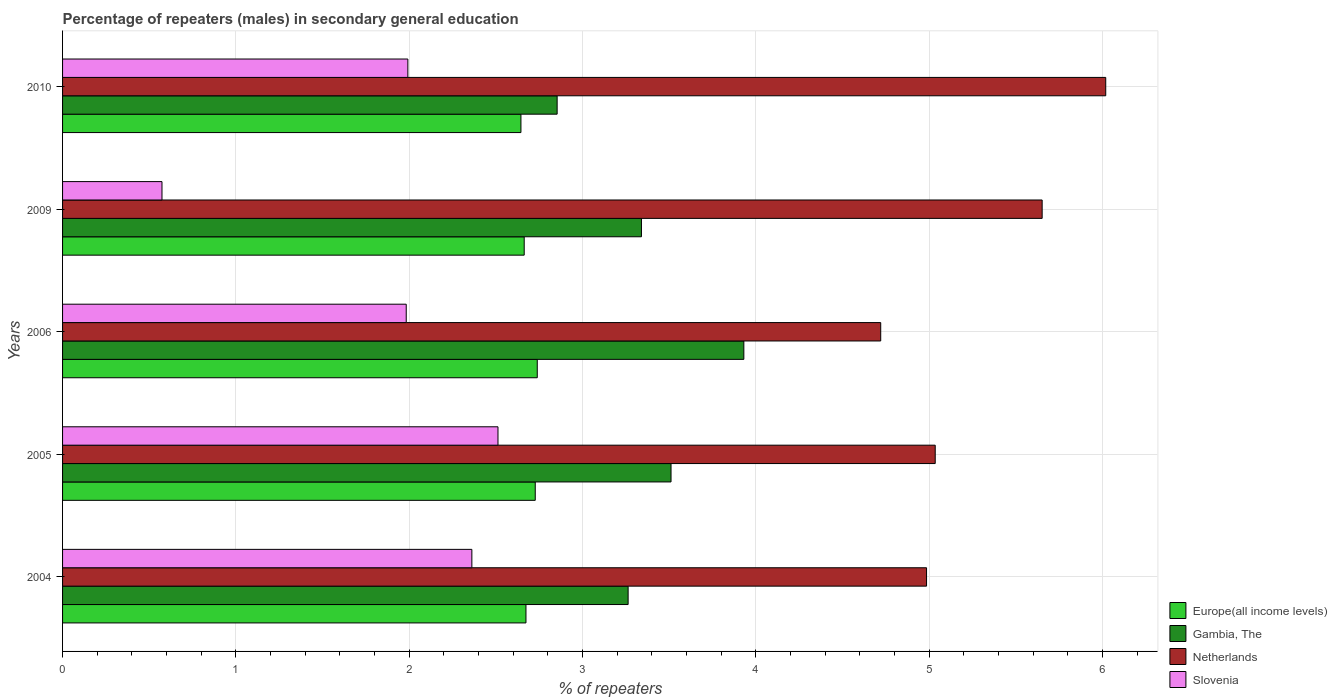How many different coloured bars are there?
Keep it short and to the point. 4. How many groups of bars are there?
Provide a succinct answer. 5. Are the number of bars on each tick of the Y-axis equal?
Your answer should be very brief. Yes. What is the label of the 3rd group of bars from the top?
Provide a short and direct response. 2006. What is the percentage of male repeaters in Gambia, The in 2004?
Provide a succinct answer. 3.26. Across all years, what is the maximum percentage of male repeaters in Slovenia?
Ensure brevity in your answer.  2.51. Across all years, what is the minimum percentage of male repeaters in Gambia, The?
Offer a terse response. 2.85. What is the total percentage of male repeaters in Gambia, The in the graph?
Your answer should be compact. 16.9. What is the difference between the percentage of male repeaters in Netherlands in 2004 and that in 2005?
Provide a short and direct response. -0.05. What is the difference between the percentage of male repeaters in Netherlands in 2004 and the percentage of male repeaters in Slovenia in 2009?
Your answer should be compact. 4.41. What is the average percentage of male repeaters in Gambia, The per year?
Offer a very short reply. 3.38. In the year 2005, what is the difference between the percentage of male repeaters in Slovenia and percentage of male repeaters in Netherlands?
Make the answer very short. -2.52. In how many years, is the percentage of male repeaters in Europe(all income levels) greater than 1.8 %?
Provide a short and direct response. 5. What is the ratio of the percentage of male repeaters in Europe(all income levels) in 2004 to that in 2010?
Offer a terse response. 1.01. Is the percentage of male repeaters in Gambia, The in 2004 less than that in 2006?
Your answer should be very brief. Yes. Is the difference between the percentage of male repeaters in Slovenia in 2005 and 2010 greater than the difference between the percentage of male repeaters in Netherlands in 2005 and 2010?
Your response must be concise. Yes. What is the difference between the highest and the second highest percentage of male repeaters in Netherlands?
Make the answer very short. 0.37. What is the difference between the highest and the lowest percentage of male repeaters in Gambia, The?
Offer a terse response. 1.08. In how many years, is the percentage of male repeaters in Netherlands greater than the average percentage of male repeaters in Netherlands taken over all years?
Provide a succinct answer. 2. Is the sum of the percentage of male repeaters in Slovenia in 2005 and 2006 greater than the maximum percentage of male repeaters in Europe(all income levels) across all years?
Provide a succinct answer. Yes. What does the 2nd bar from the top in 2004 represents?
Make the answer very short. Netherlands. Is it the case that in every year, the sum of the percentage of male repeaters in Gambia, The and percentage of male repeaters in Slovenia is greater than the percentage of male repeaters in Europe(all income levels)?
Offer a terse response. Yes. How many bars are there?
Provide a succinct answer. 20. Are the values on the major ticks of X-axis written in scientific E-notation?
Your answer should be very brief. No. Does the graph contain any zero values?
Your answer should be compact. No. Where does the legend appear in the graph?
Your response must be concise. Bottom right. How are the legend labels stacked?
Offer a terse response. Vertical. What is the title of the graph?
Make the answer very short. Percentage of repeaters (males) in secondary general education. What is the label or title of the X-axis?
Give a very brief answer. % of repeaters. What is the label or title of the Y-axis?
Offer a very short reply. Years. What is the % of repeaters of Europe(all income levels) in 2004?
Provide a short and direct response. 2.67. What is the % of repeaters in Gambia, The in 2004?
Offer a terse response. 3.26. What is the % of repeaters in Netherlands in 2004?
Make the answer very short. 4.99. What is the % of repeaters in Slovenia in 2004?
Keep it short and to the point. 2.36. What is the % of repeaters of Europe(all income levels) in 2005?
Ensure brevity in your answer.  2.73. What is the % of repeaters in Gambia, The in 2005?
Ensure brevity in your answer.  3.51. What is the % of repeaters of Netherlands in 2005?
Your response must be concise. 5.04. What is the % of repeaters of Slovenia in 2005?
Your answer should be compact. 2.51. What is the % of repeaters in Europe(all income levels) in 2006?
Offer a terse response. 2.74. What is the % of repeaters in Gambia, The in 2006?
Offer a very short reply. 3.93. What is the % of repeaters of Netherlands in 2006?
Make the answer very short. 4.72. What is the % of repeaters of Slovenia in 2006?
Make the answer very short. 1.98. What is the % of repeaters in Europe(all income levels) in 2009?
Give a very brief answer. 2.66. What is the % of repeaters in Gambia, The in 2009?
Your answer should be compact. 3.34. What is the % of repeaters of Netherlands in 2009?
Offer a terse response. 5.65. What is the % of repeaters of Slovenia in 2009?
Ensure brevity in your answer.  0.57. What is the % of repeaters in Europe(all income levels) in 2010?
Keep it short and to the point. 2.64. What is the % of repeaters of Gambia, The in 2010?
Provide a short and direct response. 2.85. What is the % of repeaters of Netherlands in 2010?
Give a very brief answer. 6.02. What is the % of repeaters in Slovenia in 2010?
Keep it short and to the point. 1.99. Across all years, what is the maximum % of repeaters of Europe(all income levels)?
Offer a very short reply. 2.74. Across all years, what is the maximum % of repeaters in Gambia, The?
Provide a succinct answer. 3.93. Across all years, what is the maximum % of repeaters in Netherlands?
Make the answer very short. 6.02. Across all years, what is the maximum % of repeaters of Slovenia?
Make the answer very short. 2.51. Across all years, what is the minimum % of repeaters of Europe(all income levels)?
Offer a very short reply. 2.64. Across all years, what is the minimum % of repeaters of Gambia, The?
Ensure brevity in your answer.  2.85. Across all years, what is the minimum % of repeaters in Netherlands?
Offer a very short reply. 4.72. Across all years, what is the minimum % of repeaters of Slovenia?
Provide a short and direct response. 0.57. What is the total % of repeaters of Europe(all income levels) in the graph?
Provide a succinct answer. 13.45. What is the total % of repeaters of Gambia, The in the graph?
Your answer should be very brief. 16.9. What is the total % of repeaters in Netherlands in the graph?
Ensure brevity in your answer.  26.41. What is the total % of repeaters of Slovenia in the graph?
Make the answer very short. 9.42. What is the difference between the % of repeaters of Europe(all income levels) in 2004 and that in 2005?
Provide a succinct answer. -0.05. What is the difference between the % of repeaters of Gambia, The in 2004 and that in 2005?
Give a very brief answer. -0.25. What is the difference between the % of repeaters of Netherlands in 2004 and that in 2005?
Your answer should be compact. -0.05. What is the difference between the % of repeaters of Slovenia in 2004 and that in 2005?
Offer a very short reply. -0.15. What is the difference between the % of repeaters of Europe(all income levels) in 2004 and that in 2006?
Give a very brief answer. -0.07. What is the difference between the % of repeaters of Gambia, The in 2004 and that in 2006?
Keep it short and to the point. -0.67. What is the difference between the % of repeaters of Netherlands in 2004 and that in 2006?
Keep it short and to the point. 0.26. What is the difference between the % of repeaters of Slovenia in 2004 and that in 2006?
Your response must be concise. 0.38. What is the difference between the % of repeaters of Europe(all income levels) in 2004 and that in 2009?
Your response must be concise. 0.01. What is the difference between the % of repeaters in Gambia, The in 2004 and that in 2009?
Offer a very short reply. -0.08. What is the difference between the % of repeaters in Netherlands in 2004 and that in 2009?
Your response must be concise. -0.67. What is the difference between the % of repeaters of Slovenia in 2004 and that in 2009?
Provide a short and direct response. 1.79. What is the difference between the % of repeaters in Europe(all income levels) in 2004 and that in 2010?
Provide a short and direct response. 0.03. What is the difference between the % of repeaters in Gambia, The in 2004 and that in 2010?
Provide a short and direct response. 0.41. What is the difference between the % of repeaters in Netherlands in 2004 and that in 2010?
Keep it short and to the point. -1.03. What is the difference between the % of repeaters of Slovenia in 2004 and that in 2010?
Your answer should be very brief. 0.37. What is the difference between the % of repeaters in Europe(all income levels) in 2005 and that in 2006?
Provide a succinct answer. -0.01. What is the difference between the % of repeaters in Gambia, The in 2005 and that in 2006?
Give a very brief answer. -0.42. What is the difference between the % of repeaters in Netherlands in 2005 and that in 2006?
Ensure brevity in your answer.  0.31. What is the difference between the % of repeaters in Slovenia in 2005 and that in 2006?
Keep it short and to the point. 0.53. What is the difference between the % of repeaters of Europe(all income levels) in 2005 and that in 2009?
Ensure brevity in your answer.  0.06. What is the difference between the % of repeaters in Gambia, The in 2005 and that in 2009?
Offer a terse response. 0.17. What is the difference between the % of repeaters of Netherlands in 2005 and that in 2009?
Your response must be concise. -0.62. What is the difference between the % of repeaters in Slovenia in 2005 and that in 2009?
Provide a succinct answer. 1.94. What is the difference between the % of repeaters of Europe(all income levels) in 2005 and that in 2010?
Provide a succinct answer. 0.08. What is the difference between the % of repeaters in Gambia, The in 2005 and that in 2010?
Your answer should be very brief. 0.66. What is the difference between the % of repeaters in Netherlands in 2005 and that in 2010?
Keep it short and to the point. -0.98. What is the difference between the % of repeaters of Slovenia in 2005 and that in 2010?
Offer a very short reply. 0.52. What is the difference between the % of repeaters of Europe(all income levels) in 2006 and that in 2009?
Offer a very short reply. 0.08. What is the difference between the % of repeaters in Gambia, The in 2006 and that in 2009?
Make the answer very short. 0.59. What is the difference between the % of repeaters of Netherlands in 2006 and that in 2009?
Provide a succinct answer. -0.93. What is the difference between the % of repeaters of Slovenia in 2006 and that in 2009?
Provide a short and direct response. 1.41. What is the difference between the % of repeaters of Europe(all income levels) in 2006 and that in 2010?
Your answer should be very brief. 0.09. What is the difference between the % of repeaters in Gambia, The in 2006 and that in 2010?
Give a very brief answer. 1.08. What is the difference between the % of repeaters of Netherlands in 2006 and that in 2010?
Provide a short and direct response. -1.3. What is the difference between the % of repeaters in Slovenia in 2006 and that in 2010?
Keep it short and to the point. -0.01. What is the difference between the % of repeaters of Europe(all income levels) in 2009 and that in 2010?
Ensure brevity in your answer.  0.02. What is the difference between the % of repeaters in Gambia, The in 2009 and that in 2010?
Provide a succinct answer. 0.49. What is the difference between the % of repeaters of Netherlands in 2009 and that in 2010?
Give a very brief answer. -0.37. What is the difference between the % of repeaters in Slovenia in 2009 and that in 2010?
Offer a terse response. -1.42. What is the difference between the % of repeaters of Europe(all income levels) in 2004 and the % of repeaters of Gambia, The in 2005?
Your answer should be very brief. -0.84. What is the difference between the % of repeaters of Europe(all income levels) in 2004 and the % of repeaters of Netherlands in 2005?
Keep it short and to the point. -2.36. What is the difference between the % of repeaters in Europe(all income levels) in 2004 and the % of repeaters in Slovenia in 2005?
Ensure brevity in your answer.  0.16. What is the difference between the % of repeaters of Gambia, The in 2004 and the % of repeaters of Netherlands in 2005?
Provide a succinct answer. -1.77. What is the difference between the % of repeaters in Gambia, The in 2004 and the % of repeaters in Slovenia in 2005?
Give a very brief answer. 0.75. What is the difference between the % of repeaters in Netherlands in 2004 and the % of repeaters in Slovenia in 2005?
Make the answer very short. 2.47. What is the difference between the % of repeaters of Europe(all income levels) in 2004 and the % of repeaters of Gambia, The in 2006?
Keep it short and to the point. -1.26. What is the difference between the % of repeaters of Europe(all income levels) in 2004 and the % of repeaters of Netherlands in 2006?
Your response must be concise. -2.05. What is the difference between the % of repeaters of Europe(all income levels) in 2004 and the % of repeaters of Slovenia in 2006?
Offer a terse response. 0.69. What is the difference between the % of repeaters of Gambia, The in 2004 and the % of repeaters of Netherlands in 2006?
Offer a terse response. -1.46. What is the difference between the % of repeaters of Gambia, The in 2004 and the % of repeaters of Slovenia in 2006?
Provide a succinct answer. 1.28. What is the difference between the % of repeaters of Netherlands in 2004 and the % of repeaters of Slovenia in 2006?
Provide a succinct answer. 3. What is the difference between the % of repeaters of Europe(all income levels) in 2004 and the % of repeaters of Gambia, The in 2009?
Your answer should be compact. -0.67. What is the difference between the % of repeaters of Europe(all income levels) in 2004 and the % of repeaters of Netherlands in 2009?
Give a very brief answer. -2.98. What is the difference between the % of repeaters of Europe(all income levels) in 2004 and the % of repeaters of Slovenia in 2009?
Give a very brief answer. 2.1. What is the difference between the % of repeaters of Gambia, The in 2004 and the % of repeaters of Netherlands in 2009?
Ensure brevity in your answer.  -2.39. What is the difference between the % of repeaters in Gambia, The in 2004 and the % of repeaters in Slovenia in 2009?
Make the answer very short. 2.69. What is the difference between the % of repeaters of Netherlands in 2004 and the % of repeaters of Slovenia in 2009?
Keep it short and to the point. 4.41. What is the difference between the % of repeaters in Europe(all income levels) in 2004 and the % of repeaters in Gambia, The in 2010?
Ensure brevity in your answer.  -0.18. What is the difference between the % of repeaters in Europe(all income levels) in 2004 and the % of repeaters in Netherlands in 2010?
Provide a succinct answer. -3.35. What is the difference between the % of repeaters of Europe(all income levels) in 2004 and the % of repeaters of Slovenia in 2010?
Provide a succinct answer. 0.68. What is the difference between the % of repeaters of Gambia, The in 2004 and the % of repeaters of Netherlands in 2010?
Ensure brevity in your answer.  -2.76. What is the difference between the % of repeaters of Gambia, The in 2004 and the % of repeaters of Slovenia in 2010?
Provide a short and direct response. 1.27. What is the difference between the % of repeaters of Netherlands in 2004 and the % of repeaters of Slovenia in 2010?
Your answer should be very brief. 2.99. What is the difference between the % of repeaters of Europe(all income levels) in 2005 and the % of repeaters of Gambia, The in 2006?
Provide a succinct answer. -1.2. What is the difference between the % of repeaters in Europe(all income levels) in 2005 and the % of repeaters in Netherlands in 2006?
Offer a very short reply. -1.99. What is the difference between the % of repeaters in Europe(all income levels) in 2005 and the % of repeaters in Slovenia in 2006?
Offer a terse response. 0.74. What is the difference between the % of repeaters of Gambia, The in 2005 and the % of repeaters of Netherlands in 2006?
Offer a terse response. -1.21. What is the difference between the % of repeaters in Gambia, The in 2005 and the % of repeaters in Slovenia in 2006?
Offer a terse response. 1.53. What is the difference between the % of repeaters of Netherlands in 2005 and the % of repeaters of Slovenia in 2006?
Give a very brief answer. 3.05. What is the difference between the % of repeaters of Europe(all income levels) in 2005 and the % of repeaters of Gambia, The in 2009?
Ensure brevity in your answer.  -0.61. What is the difference between the % of repeaters of Europe(all income levels) in 2005 and the % of repeaters of Netherlands in 2009?
Offer a very short reply. -2.92. What is the difference between the % of repeaters in Europe(all income levels) in 2005 and the % of repeaters in Slovenia in 2009?
Your answer should be compact. 2.15. What is the difference between the % of repeaters of Gambia, The in 2005 and the % of repeaters of Netherlands in 2009?
Keep it short and to the point. -2.14. What is the difference between the % of repeaters in Gambia, The in 2005 and the % of repeaters in Slovenia in 2009?
Keep it short and to the point. 2.94. What is the difference between the % of repeaters of Netherlands in 2005 and the % of repeaters of Slovenia in 2009?
Ensure brevity in your answer.  4.46. What is the difference between the % of repeaters of Europe(all income levels) in 2005 and the % of repeaters of Gambia, The in 2010?
Your answer should be very brief. -0.13. What is the difference between the % of repeaters in Europe(all income levels) in 2005 and the % of repeaters in Netherlands in 2010?
Give a very brief answer. -3.29. What is the difference between the % of repeaters of Europe(all income levels) in 2005 and the % of repeaters of Slovenia in 2010?
Give a very brief answer. 0.74. What is the difference between the % of repeaters of Gambia, The in 2005 and the % of repeaters of Netherlands in 2010?
Ensure brevity in your answer.  -2.51. What is the difference between the % of repeaters of Gambia, The in 2005 and the % of repeaters of Slovenia in 2010?
Provide a succinct answer. 1.52. What is the difference between the % of repeaters of Netherlands in 2005 and the % of repeaters of Slovenia in 2010?
Make the answer very short. 3.04. What is the difference between the % of repeaters in Europe(all income levels) in 2006 and the % of repeaters in Gambia, The in 2009?
Offer a terse response. -0.6. What is the difference between the % of repeaters of Europe(all income levels) in 2006 and the % of repeaters of Netherlands in 2009?
Offer a very short reply. -2.91. What is the difference between the % of repeaters of Europe(all income levels) in 2006 and the % of repeaters of Slovenia in 2009?
Ensure brevity in your answer.  2.17. What is the difference between the % of repeaters of Gambia, The in 2006 and the % of repeaters of Netherlands in 2009?
Offer a terse response. -1.72. What is the difference between the % of repeaters of Gambia, The in 2006 and the % of repeaters of Slovenia in 2009?
Your answer should be compact. 3.36. What is the difference between the % of repeaters in Netherlands in 2006 and the % of repeaters in Slovenia in 2009?
Give a very brief answer. 4.15. What is the difference between the % of repeaters in Europe(all income levels) in 2006 and the % of repeaters in Gambia, The in 2010?
Make the answer very short. -0.11. What is the difference between the % of repeaters of Europe(all income levels) in 2006 and the % of repeaters of Netherlands in 2010?
Make the answer very short. -3.28. What is the difference between the % of repeaters in Europe(all income levels) in 2006 and the % of repeaters in Slovenia in 2010?
Your answer should be compact. 0.75. What is the difference between the % of repeaters of Gambia, The in 2006 and the % of repeaters of Netherlands in 2010?
Your answer should be compact. -2.09. What is the difference between the % of repeaters in Gambia, The in 2006 and the % of repeaters in Slovenia in 2010?
Your answer should be compact. 1.94. What is the difference between the % of repeaters in Netherlands in 2006 and the % of repeaters in Slovenia in 2010?
Keep it short and to the point. 2.73. What is the difference between the % of repeaters in Europe(all income levels) in 2009 and the % of repeaters in Gambia, The in 2010?
Keep it short and to the point. -0.19. What is the difference between the % of repeaters in Europe(all income levels) in 2009 and the % of repeaters in Netherlands in 2010?
Ensure brevity in your answer.  -3.36. What is the difference between the % of repeaters in Europe(all income levels) in 2009 and the % of repeaters in Slovenia in 2010?
Your answer should be compact. 0.67. What is the difference between the % of repeaters of Gambia, The in 2009 and the % of repeaters of Netherlands in 2010?
Your answer should be very brief. -2.68. What is the difference between the % of repeaters of Gambia, The in 2009 and the % of repeaters of Slovenia in 2010?
Keep it short and to the point. 1.35. What is the difference between the % of repeaters in Netherlands in 2009 and the % of repeaters in Slovenia in 2010?
Provide a short and direct response. 3.66. What is the average % of repeaters in Europe(all income levels) per year?
Ensure brevity in your answer.  2.69. What is the average % of repeaters of Gambia, The per year?
Offer a very short reply. 3.38. What is the average % of repeaters in Netherlands per year?
Ensure brevity in your answer.  5.28. What is the average % of repeaters in Slovenia per year?
Your answer should be compact. 1.88. In the year 2004, what is the difference between the % of repeaters in Europe(all income levels) and % of repeaters in Gambia, The?
Keep it short and to the point. -0.59. In the year 2004, what is the difference between the % of repeaters of Europe(all income levels) and % of repeaters of Netherlands?
Provide a short and direct response. -2.31. In the year 2004, what is the difference between the % of repeaters of Europe(all income levels) and % of repeaters of Slovenia?
Give a very brief answer. 0.31. In the year 2004, what is the difference between the % of repeaters of Gambia, The and % of repeaters of Netherlands?
Offer a terse response. -1.72. In the year 2004, what is the difference between the % of repeaters in Gambia, The and % of repeaters in Slovenia?
Provide a succinct answer. 0.9. In the year 2004, what is the difference between the % of repeaters in Netherlands and % of repeaters in Slovenia?
Offer a very short reply. 2.62. In the year 2005, what is the difference between the % of repeaters in Europe(all income levels) and % of repeaters in Gambia, The?
Provide a short and direct response. -0.78. In the year 2005, what is the difference between the % of repeaters in Europe(all income levels) and % of repeaters in Netherlands?
Your answer should be very brief. -2.31. In the year 2005, what is the difference between the % of repeaters of Europe(all income levels) and % of repeaters of Slovenia?
Keep it short and to the point. 0.21. In the year 2005, what is the difference between the % of repeaters of Gambia, The and % of repeaters of Netherlands?
Make the answer very short. -1.52. In the year 2005, what is the difference between the % of repeaters in Gambia, The and % of repeaters in Slovenia?
Provide a short and direct response. 1. In the year 2005, what is the difference between the % of repeaters of Netherlands and % of repeaters of Slovenia?
Your answer should be very brief. 2.52. In the year 2006, what is the difference between the % of repeaters of Europe(all income levels) and % of repeaters of Gambia, The?
Your answer should be very brief. -1.19. In the year 2006, what is the difference between the % of repeaters in Europe(all income levels) and % of repeaters in Netherlands?
Provide a succinct answer. -1.98. In the year 2006, what is the difference between the % of repeaters of Europe(all income levels) and % of repeaters of Slovenia?
Your answer should be very brief. 0.76. In the year 2006, what is the difference between the % of repeaters in Gambia, The and % of repeaters in Netherlands?
Offer a terse response. -0.79. In the year 2006, what is the difference between the % of repeaters in Gambia, The and % of repeaters in Slovenia?
Keep it short and to the point. 1.95. In the year 2006, what is the difference between the % of repeaters of Netherlands and % of repeaters of Slovenia?
Make the answer very short. 2.74. In the year 2009, what is the difference between the % of repeaters of Europe(all income levels) and % of repeaters of Gambia, The?
Your response must be concise. -0.68. In the year 2009, what is the difference between the % of repeaters of Europe(all income levels) and % of repeaters of Netherlands?
Your answer should be compact. -2.99. In the year 2009, what is the difference between the % of repeaters in Europe(all income levels) and % of repeaters in Slovenia?
Your answer should be very brief. 2.09. In the year 2009, what is the difference between the % of repeaters in Gambia, The and % of repeaters in Netherlands?
Provide a succinct answer. -2.31. In the year 2009, what is the difference between the % of repeaters of Gambia, The and % of repeaters of Slovenia?
Keep it short and to the point. 2.77. In the year 2009, what is the difference between the % of repeaters of Netherlands and % of repeaters of Slovenia?
Provide a succinct answer. 5.08. In the year 2010, what is the difference between the % of repeaters of Europe(all income levels) and % of repeaters of Gambia, The?
Ensure brevity in your answer.  -0.21. In the year 2010, what is the difference between the % of repeaters in Europe(all income levels) and % of repeaters in Netherlands?
Keep it short and to the point. -3.37. In the year 2010, what is the difference between the % of repeaters of Europe(all income levels) and % of repeaters of Slovenia?
Your answer should be very brief. 0.65. In the year 2010, what is the difference between the % of repeaters of Gambia, The and % of repeaters of Netherlands?
Offer a very short reply. -3.17. In the year 2010, what is the difference between the % of repeaters of Gambia, The and % of repeaters of Slovenia?
Ensure brevity in your answer.  0.86. In the year 2010, what is the difference between the % of repeaters of Netherlands and % of repeaters of Slovenia?
Provide a succinct answer. 4.03. What is the ratio of the % of repeaters in Europe(all income levels) in 2004 to that in 2005?
Give a very brief answer. 0.98. What is the ratio of the % of repeaters of Gambia, The in 2004 to that in 2005?
Provide a short and direct response. 0.93. What is the ratio of the % of repeaters in Slovenia in 2004 to that in 2005?
Offer a terse response. 0.94. What is the ratio of the % of repeaters of Europe(all income levels) in 2004 to that in 2006?
Keep it short and to the point. 0.98. What is the ratio of the % of repeaters in Gambia, The in 2004 to that in 2006?
Provide a succinct answer. 0.83. What is the ratio of the % of repeaters of Netherlands in 2004 to that in 2006?
Your answer should be compact. 1.06. What is the ratio of the % of repeaters of Slovenia in 2004 to that in 2006?
Provide a succinct answer. 1.19. What is the ratio of the % of repeaters in Europe(all income levels) in 2004 to that in 2009?
Provide a short and direct response. 1. What is the ratio of the % of repeaters of Netherlands in 2004 to that in 2009?
Make the answer very short. 0.88. What is the ratio of the % of repeaters in Slovenia in 2004 to that in 2009?
Provide a short and direct response. 4.12. What is the ratio of the % of repeaters in Europe(all income levels) in 2004 to that in 2010?
Give a very brief answer. 1.01. What is the ratio of the % of repeaters of Gambia, The in 2004 to that in 2010?
Your answer should be very brief. 1.14. What is the ratio of the % of repeaters in Netherlands in 2004 to that in 2010?
Your response must be concise. 0.83. What is the ratio of the % of repeaters of Slovenia in 2004 to that in 2010?
Keep it short and to the point. 1.19. What is the ratio of the % of repeaters of Europe(all income levels) in 2005 to that in 2006?
Offer a very short reply. 1. What is the ratio of the % of repeaters in Gambia, The in 2005 to that in 2006?
Your answer should be very brief. 0.89. What is the ratio of the % of repeaters in Netherlands in 2005 to that in 2006?
Ensure brevity in your answer.  1.07. What is the ratio of the % of repeaters in Slovenia in 2005 to that in 2006?
Your answer should be compact. 1.27. What is the ratio of the % of repeaters in Europe(all income levels) in 2005 to that in 2009?
Keep it short and to the point. 1.02. What is the ratio of the % of repeaters in Gambia, The in 2005 to that in 2009?
Your answer should be very brief. 1.05. What is the ratio of the % of repeaters in Netherlands in 2005 to that in 2009?
Provide a succinct answer. 0.89. What is the ratio of the % of repeaters in Slovenia in 2005 to that in 2009?
Your answer should be very brief. 4.38. What is the ratio of the % of repeaters of Europe(all income levels) in 2005 to that in 2010?
Your answer should be very brief. 1.03. What is the ratio of the % of repeaters of Gambia, The in 2005 to that in 2010?
Your answer should be compact. 1.23. What is the ratio of the % of repeaters of Netherlands in 2005 to that in 2010?
Your answer should be compact. 0.84. What is the ratio of the % of repeaters of Slovenia in 2005 to that in 2010?
Provide a succinct answer. 1.26. What is the ratio of the % of repeaters of Europe(all income levels) in 2006 to that in 2009?
Your answer should be compact. 1.03. What is the ratio of the % of repeaters in Gambia, The in 2006 to that in 2009?
Your response must be concise. 1.18. What is the ratio of the % of repeaters in Netherlands in 2006 to that in 2009?
Ensure brevity in your answer.  0.84. What is the ratio of the % of repeaters in Slovenia in 2006 to that in 2009?
Your answer should be compact. 3.46. What is the ratio of the % of repeaters in Europe(all income levels) in 2006 to that in 2010?
Your answer should be compact. 1.04. What is the ratio of the % of repeaters in Gambia, The in 2006 to that in 2010?
Provide a short and direct response. 1.38. What is the ratio of the % of repeaters in Netherlands in 2006 to that in 2010?
Provide a succinct answer. 0.78. What is the ratio of the % of repeaters in Slovenia in 2006 to that in 2010?
Your answer should be very brief. 1. What is the ratio of the % of repeaters of Europe(all income levels) in 2009 to that in 2010?
Provide a succinct answer. 1.01. What is the ratio of the % of repeaters in Gambia, The in 2009 to that in 2010?
Offer a very short reply. 1.17. What is the ratio of the % of repeaters of Netherlands in 2009 to that in 2010?
Your response must be concise. 0.94. What is the ratio of the % of repeaters of Slovenia in 2009 to that in 2010?
Your response must be concise. 0.29. What is the difference between the highest and the second highest % of repeaters of Europe(all income levels)?
Keep it short and to the point. 0.01. What is the difference between the highest and the second highest % of repeaters in Gambia, The?
Provide a succinct answer. 0.42. What is the difference between the highest and the second highest % of repeaters in Netherlands?
Your answer should be compact. 0.37. What is the difference between the highest and the second highest % of repeaters in Slovenia?
Offer a terse response. 0.15. What is the difference between the highest and the lowest % of repeaters in Europe(all income levels)?
Your response must be concise. 0.09. What is the difference between the highest and the lowest % of repeaters in Gambia, The?
Your response must be concise. 1.08. What is the difference between the highest and the lowest % of repeaters in Netherlands?
Provide a short and direct response. 1.3. What is the difference between the highest and the lowest % of repeaters in Slovenia?
Your answer should be very brief. 1.94. 